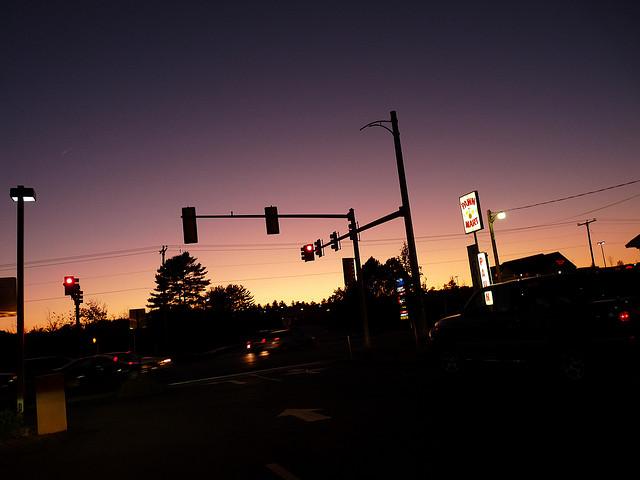Was the pic taken during the night?
Short answer required. Yes. Are the street lamps in the picture lit?
Short answer required. Yes. Are there clouds in the sky?
Keep it brief. No. What color are the traffic lights?
Answer briefly. Red. 